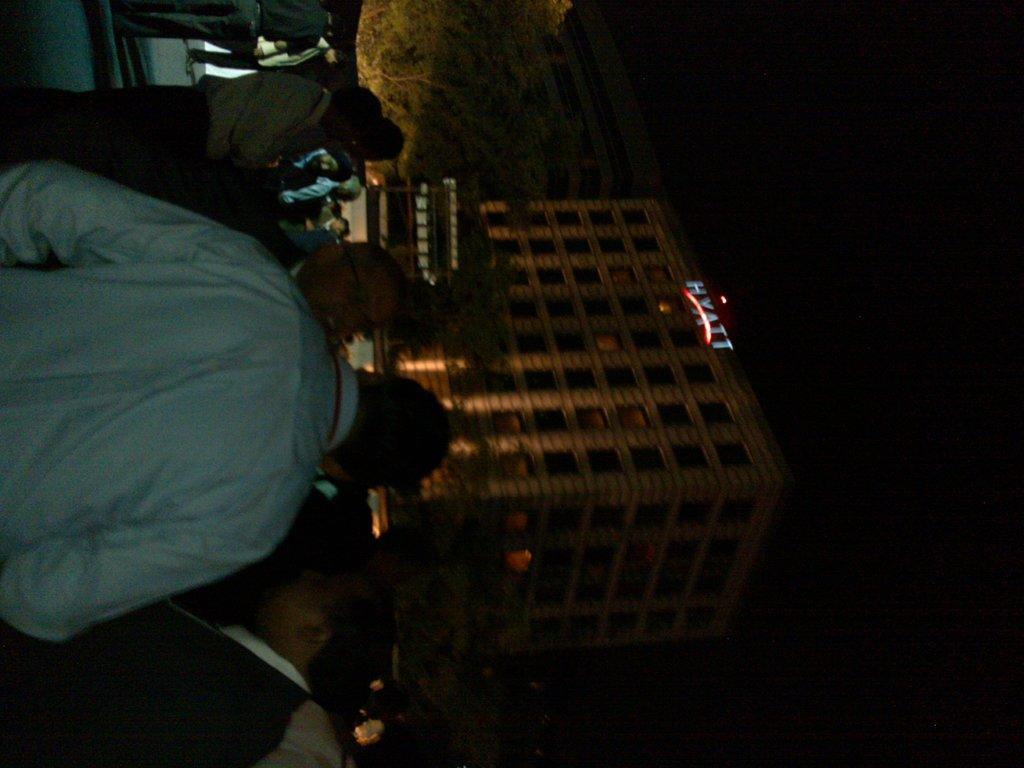Can you describe this image briefly? In the picture I can see building, in front we can see some people are standing and there is a tree. 